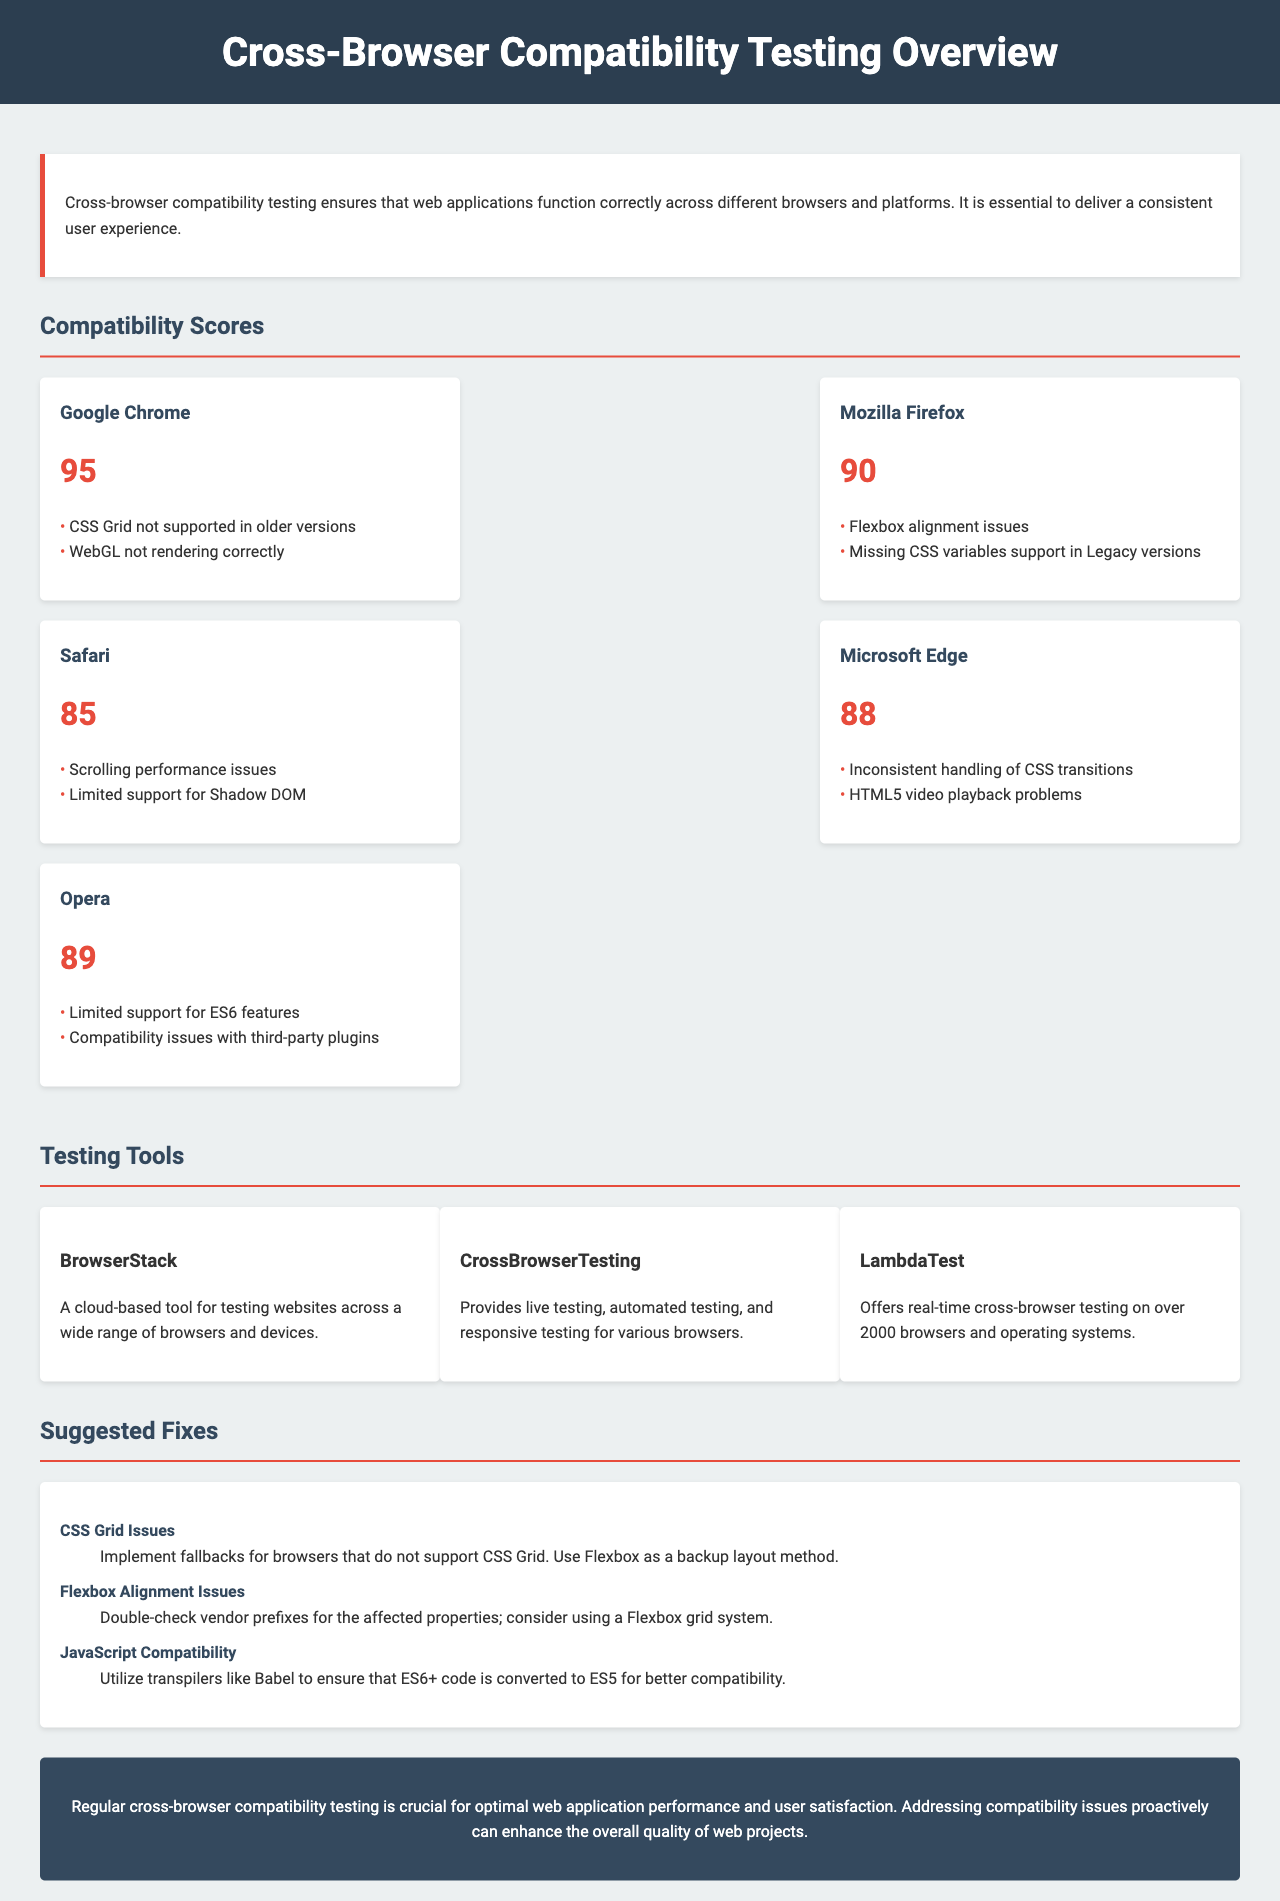What is the compatibility score for Google Chrome? The compatibility score for Google Chrome is listed directly in the document.
Answer: 95 What issues are related to Safari? The issues are listed for Safari under the compatibility scores section, specifically detailing the performance problems it faces.
Answer: Scrolling performance issues, Limited support for Shadow DOM Which testing tool offers real-time testing? The document mentions specific tools and their features; this tool is explicitly described for providing live testing.
Answer: CrossBrowserTesting What is the suggested fix for Flexbox alignment issues? The suggested fix is directly stated in the document under the suggested fixes section.
Answer: Double-check vendor prefixes for the affected properties; consider using a Flexbox grid system What is the lowest compatibility score mentioned in the document? This score can be found in the compatibility scores section by comparing each browser's score.
Answer: 85 Which browser has a compatibility score of 88? The score is directly provided in the compatibility scores section for the specified browser.
Answer: Microsoft Edge What is one testing tool mentioned that is cloud-based? The document lists testing tools; this one describes its functionality as cloud-based.
Answer: BrowserStack What is the main purpose of cross-browser compatibility testing? The introduction section outlines the main purpose of this testing clearly.
Answer: To ensure that web applications function correctly across different browsers and platforms 